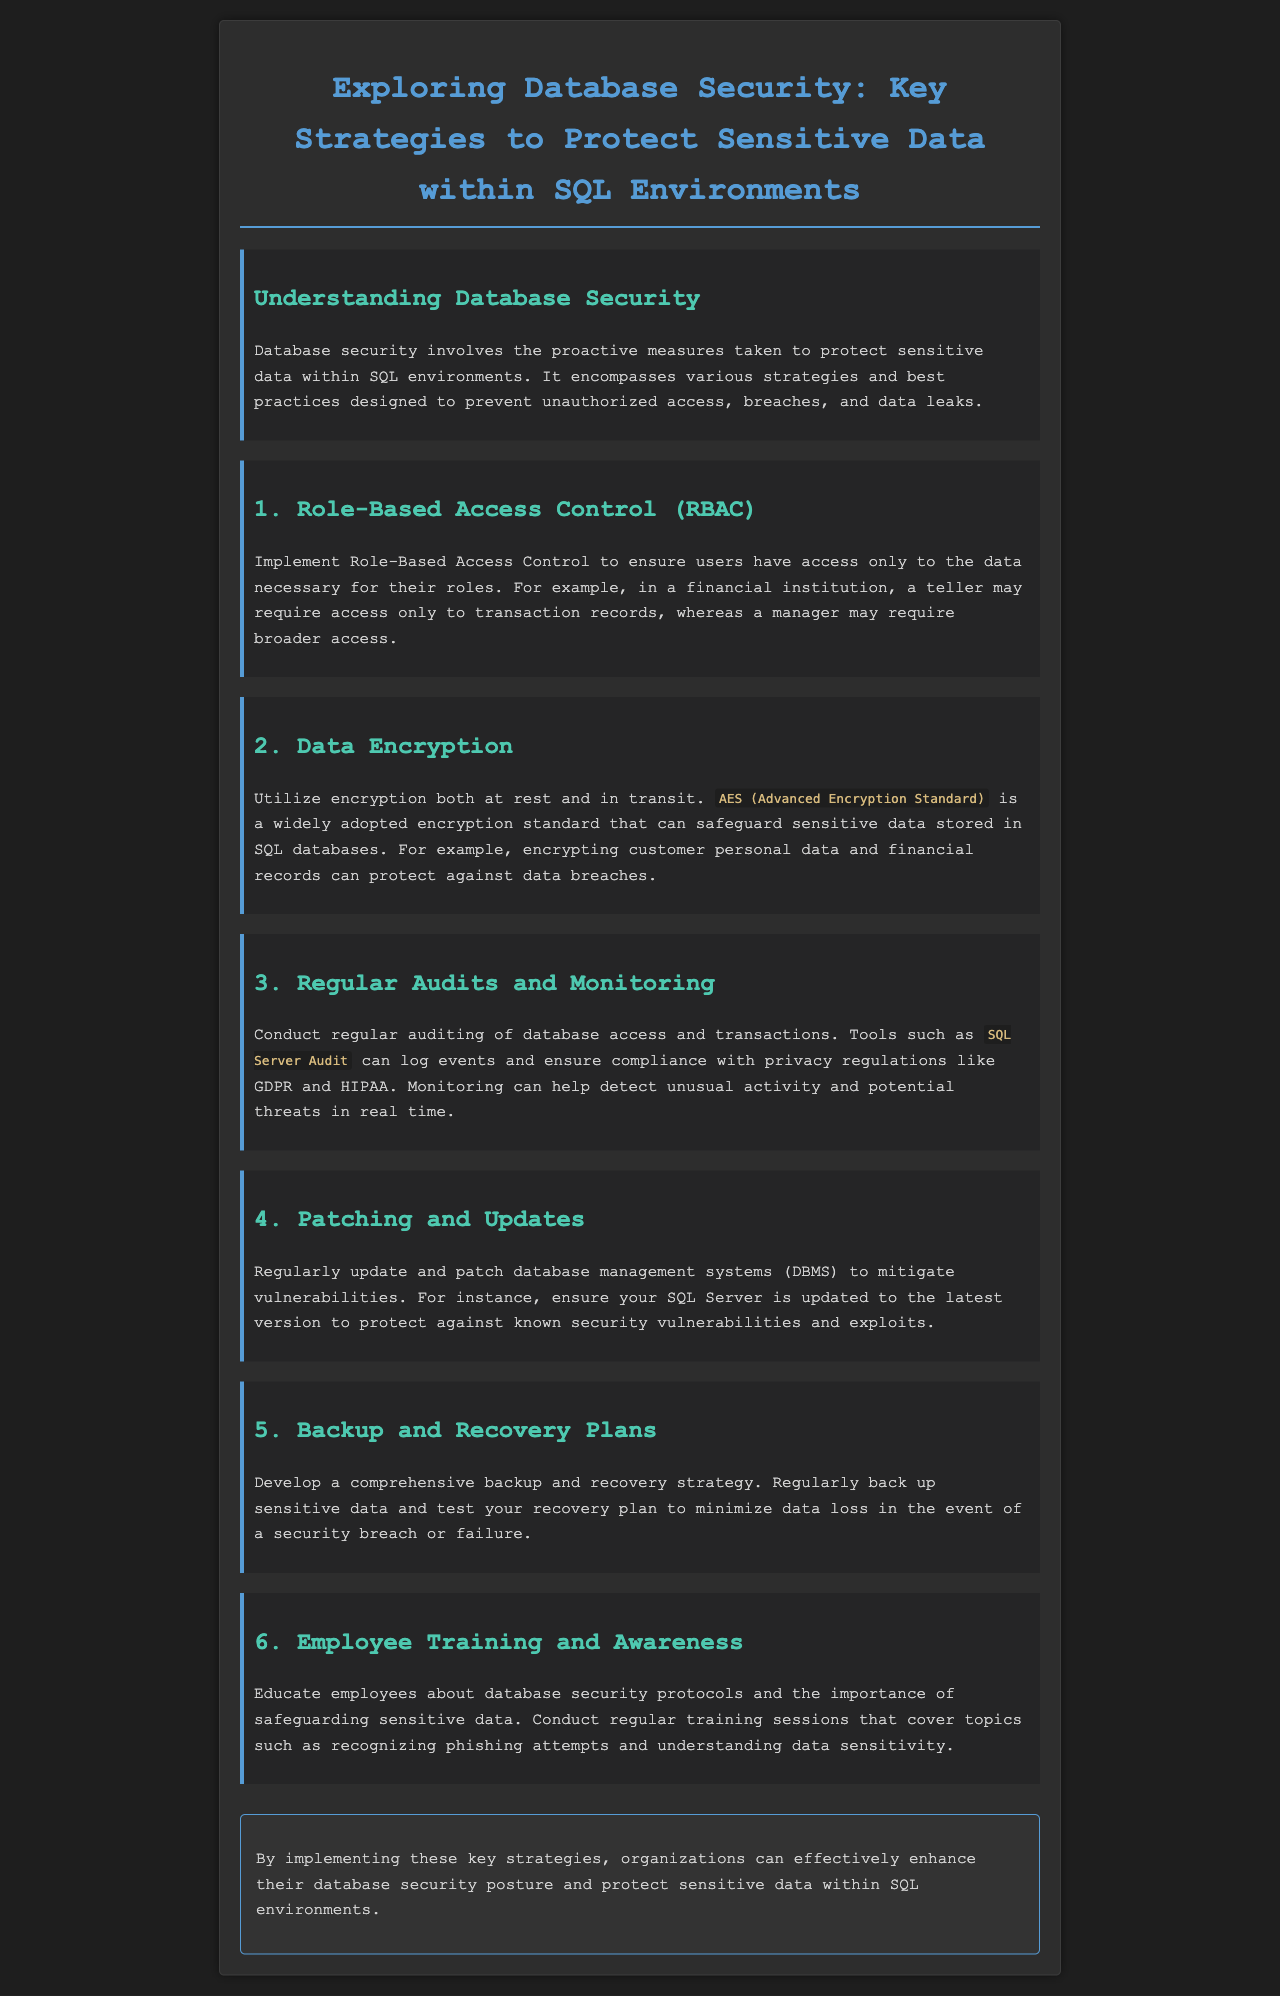What is the main focus of the newsletter? The newsletter discusses the proactive measures taken to protect sensitive data within SQL environments.
Answer: Database security What does RBAC stand for? RBAC is mentioned as a key strategy for database security.
Answer: Role-Based Access Control What encryption standard is commonly used? The document specifies a widely adopted encryption standard for safeguarding sensitive data.
Answer: AES Which auditing tool is mentioned in the newsletter? The newsletter suggests using a specific tool for auditing database access.
Answer: SQL Server Audit What should be regularly updated to mitigate vulnerabilities? The document highlights the importance of keeping a specific software component up to date.
Answer: Database management systems What strategy should be developed to minimize data loss? A specific plan is recommended to protect against the impacts of breaches or failures.
Answer: Backup and recovery plans What training is suggested for employees? The document emphasizes educating employees on specific security protocols.
Answer: Database security protocols What is the purpose of monitoring database access? Monitoring is suggested as a way to detect potential threats.
Answer: Detect unusual activity How often should audits be conducted? The document advises undertaking audits on a regular basis.
Answer: Regularly 